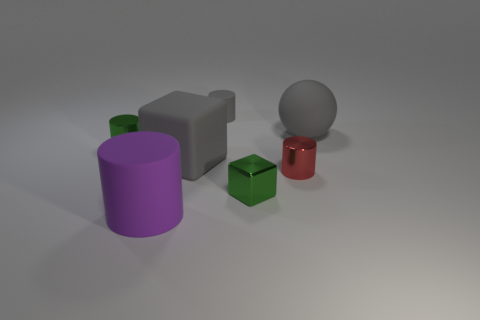What material is the big object that is both behind the small red cylinder and to the left of the large matte ball?
Provide a short and direct response. Rubber. Do the purple thing and the red metallic object have the same shape?
Ensure brevity in your answer.  Yes. There is a metal block; what number of tiny things are to the left of it?
Make the answer very short. 2. Is the size of the gray matte thing that is in front of the green cylinder the same as the large purple cylinder?
Make the answer very short. Yes. There is another shiny object that is the same shape as the red object; what is its color?
Your response must be concise. Green. Is there any other thing that has the same shape as the small red object?
Make the answer very short. Yes. What is the shape of the green object right of the small gray cylinder?
Offer a terse response. Cube. What number of red objects are the same shape as the tiny gray object?
Keep it short and to the point. 1. Do the matte cylinder that is to the right of the large gray block and the metal cylinder to the left of the purple rubber thing have the same color?
Your response must be concise. No. How many objects are either large green shiny blocks or large gray matte spheres?
Give a very brief answer. 1. 